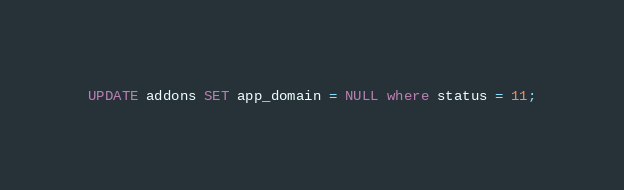Convert code to text. <code><loc_0><loc_0><loc_500><loc_500><_SQL_>UPDATE addons SET app_domain = NULL where status = 11;
</code> 